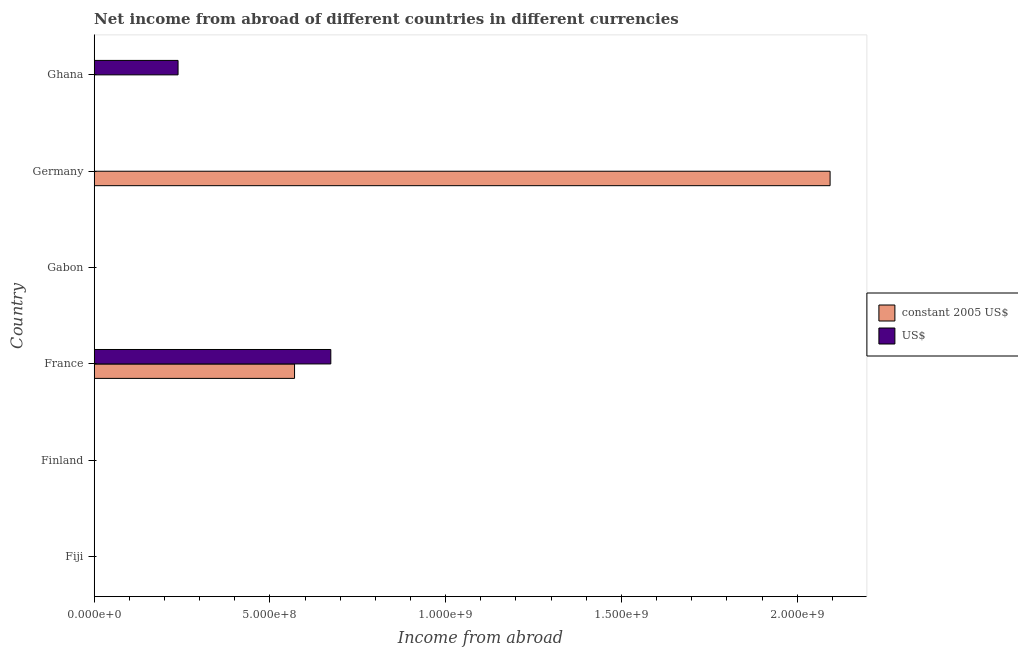How many different coloured bars are there?
Give a very brief answer. 2. How many bars are there on the 6th tick from the top?
Offer a terse response. 0. What is the label of the 3rd group of bars from the top?
Provide a short and direct response. Gabon. What is the income from abroad in us$ in Germany?
Provide a succinct answer. 0. Across all countries, what is the maximum income from abroad in us$?
Ensure brevity in your answer.  6.73e+08. In which country was the income from abroad in constant 2005 us$ maximum?
Your answer should be very brief. Germany. What is the total income from abroad in constant 2005 us$ in the graph?
Offer a terse response. 2.66e+09. What is the average income from abroad in us$ per country?
Ensure brevity in your answer.  1.52e+08. What is the difference between the income from abroad in us$ and income from abroad in constant 2005 us$ in France?
Your answer should be very brief. 1.03e+08. In how many countries, is the income from abroad in constant 2005 us$ greater than 200000000 units?
Offer a terse response. 2. What is the ratio of the income from abroad in us$ in France to that in Ghana?
Ensure brevity in your answer.  2.82. Is the income from abroad in constant 2005 us$ in France less than that in Germany?
Give a very brief answer. Yes. What is the difference between the highest and the lowest income from abroad in us$?
Offer a very short reply. 6.73e+08. How many countries are there in the graph?
Offer a very short reply. 6. Are the values on the major ticks of X-axis written in scientific E-notation?
Your answer should be very brief. Yes. How many legend labels are there?
Your answer should be very brief. 2. How are the legend labels stacked?
Offer a very short reply. Vertical. What is the title of the graph?
Give a very brief answer. Net income from abroad of different countries in different currencies. Does "Methane emissions" appear as one of the legend labels in the graph?
Provide a succinct answer. No. What is the label or title of the X-axis?
Your answer should be compact. Income from abroad. What is the label or title of the Y-axis?
Your response must be concise. Country. What is the Income from abroad of US$ in Fiji?
Offer a terse response. 0. What is the Income from abroad of US$ in Finland?
Provide a short and direct response. 0. What is the Income from abroad in constant 2005 US$ in France?
Provide a succinct answer. 5.70e+08. What is the Income from abroad of US$ in France?
Your answer should be compact. 6.73e+08. What is the Income from abroad of constant 2005 US$ in Gabon?
Provide a short and direct response. 0. What is the Income from abroad in constant 2005 US$ in Germany?
Your response must be concise. 2.09e+09. What is the Income from abroad in US$ in Germany?
Your response must be concise. 0. What is the Income from abroad in constant 2005 US$ in Ghana?
Offer a very short reply. 0. What is the Income from abroad in US$ in Ghana?
Give a very brief answer. 2.39e+08. Across all countries, what is the maximum Income from abroad in constant 2005 US$?
Ensure brevity in your answer.  2.09e+09. Across all countries, what is the maximum Income from abroad of US$?
Your answer should be very brief. 6.73e+08. Across all countries, what is the minimum Income from abroad of US$?
Provide a short and direct response. 0. What is the total Income from abroad in constant 2005 US$ in the graph?
Offer a terse response. 2.66e+09. What is the total Income from abroad of US$ in the graph?
Keep it short and to the point. 9.12e+08. What is the difference between the Income from abroad of constant 2005 US$ in France and that in Germany?
Provide a succinct answer. -1.52e+09. What is the difference between the Income from abroad in US$ in France and that in Ghana?
Your answer should be very brief. 4.35e+08. What is the difference between the Income from abroad in constant 2005 US$ in France and the Income from abroad in US$ in Ghana?
Make the answer very short. 3.31e+08. What is the difference between the Income from abroad in constant 2005 US$ in Germany and the Income from abroad in US$ in Ghana?
Your response must be concise. 1.86e+09. What is the average Income from abroad of constant 2005 US$ per country?
Provide a short and direct response. 4.44e+08. What is the average Income from abroad in US$ per country?
Give a very brief answer. 1.52e+08. What is the difference between the Income from abroad of constant 2005 US$ and Income from abroad of US$ in France?
Your response must be concise. -1.03e+08. What is the ratio of the Income from abroad in constant 2005 US$ in France to that in Germany?
Make the answer very short. 0.27. What is the ratio of the Income from abroad of US$ in France to that in Ghana?
Provide a succinct answer. 2.82. What is the difference between the highest and the lowest Income from abroad of constant 2005 US$?
Your response must be concise. 2.09e+09. What is the difference between the highest and the lowest Income from abroad of US$?
Offer a terse response. 6.73e+08. 